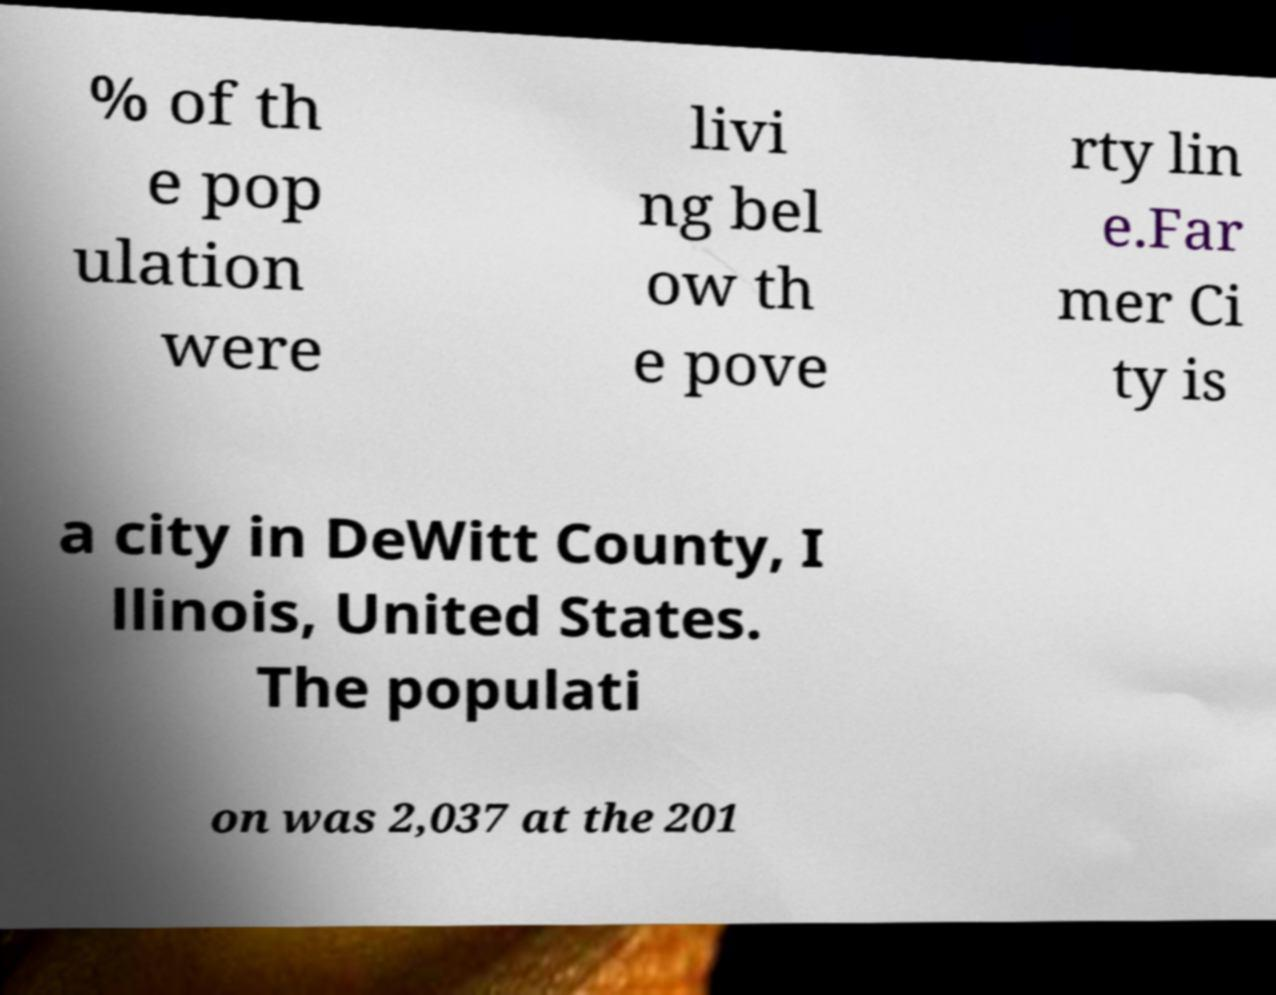I need the written content from this picture converted into text. Can you do that? % of th e pop ulation were livi ng bel ow th e pove rty lin e.Far mer Ci ty is a city in DeWitt County, I llinois, United States. The populati on was 2,037 at the 201 